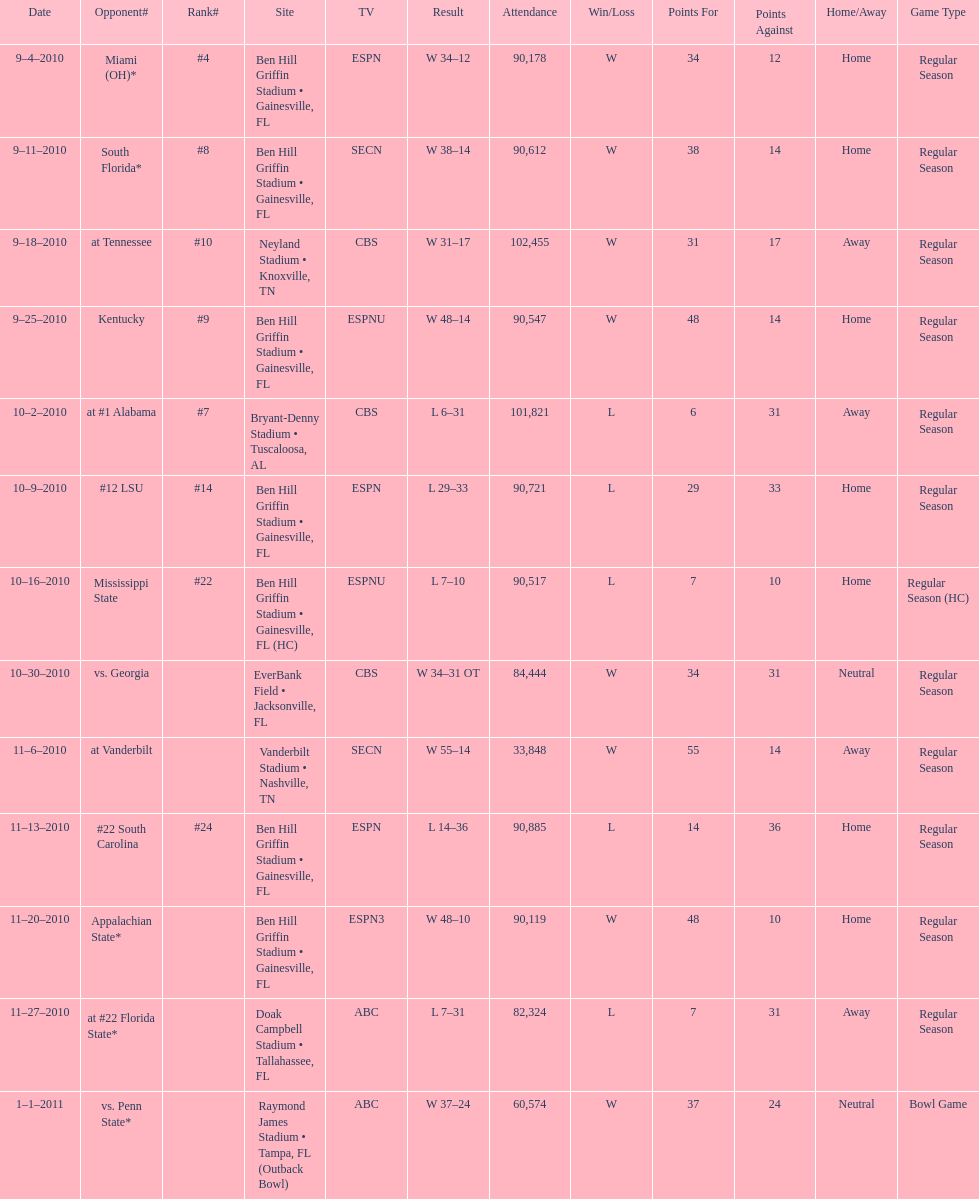The gators won the game on september 25, 2010. who won the previous game? Gators. 